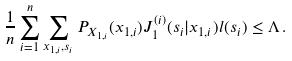Convert formula to latex. <formula><loc_0><loc_0><loc_500><loc_500>\frac { 1 } { n } \sum _ { i = 1 } ^ { n } \sum _ { x _ { 1 , i } , s _ { i } } P _ { X _ { 1 , i } } ( x _ { 1 , i } ) J _ { 1 } ^ { ( i ) } ( s _ { i } | x _ { 1 , i } ) l ( s _ { i } ) \leq \Lambda \, .</formula> 